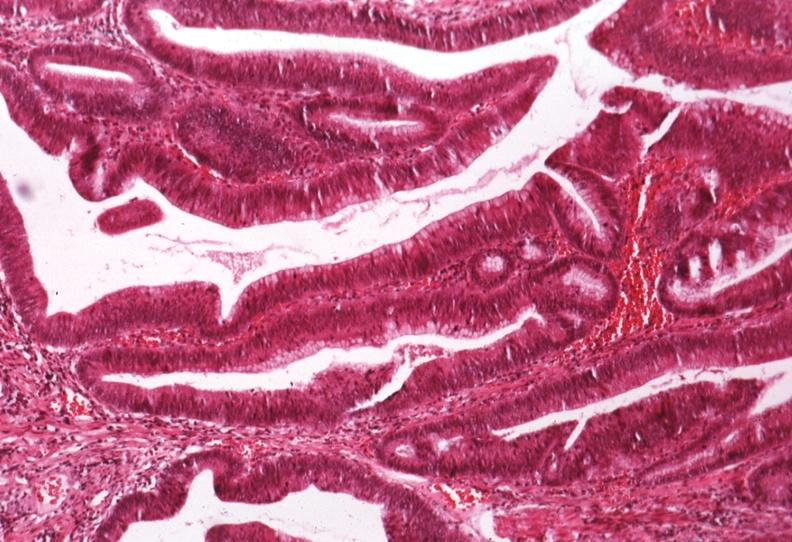s villous adenoma present?
Answer the question using a single word or phrase. Yes 